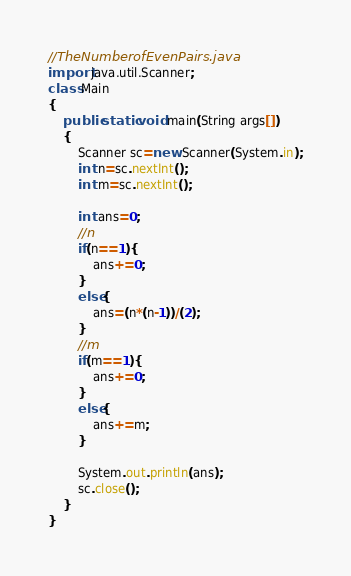Convert code to text. <code><loc_0><loc_0><loc_500><loc_500><_Java_>//TheNumberofEvenPairs.java
import java.util.Scanner;
class Main
{
	public static void main(String args[])
	{
		Scanner sc=new Scanner(System.in);
		int n=sc.nextInt();
        int m=sc.nextInt();

        int ans=0;
        //n
        if(n==1){
            ans+=0;
        }
        else{
            ans=(n*(n-1))/(2);
        }
        //m
        if(m==1){
            ans+=0;
        }
        else{
            ans+=m;
        }

        System.out.println(ans);
        sc.close();
    }
}</code> 